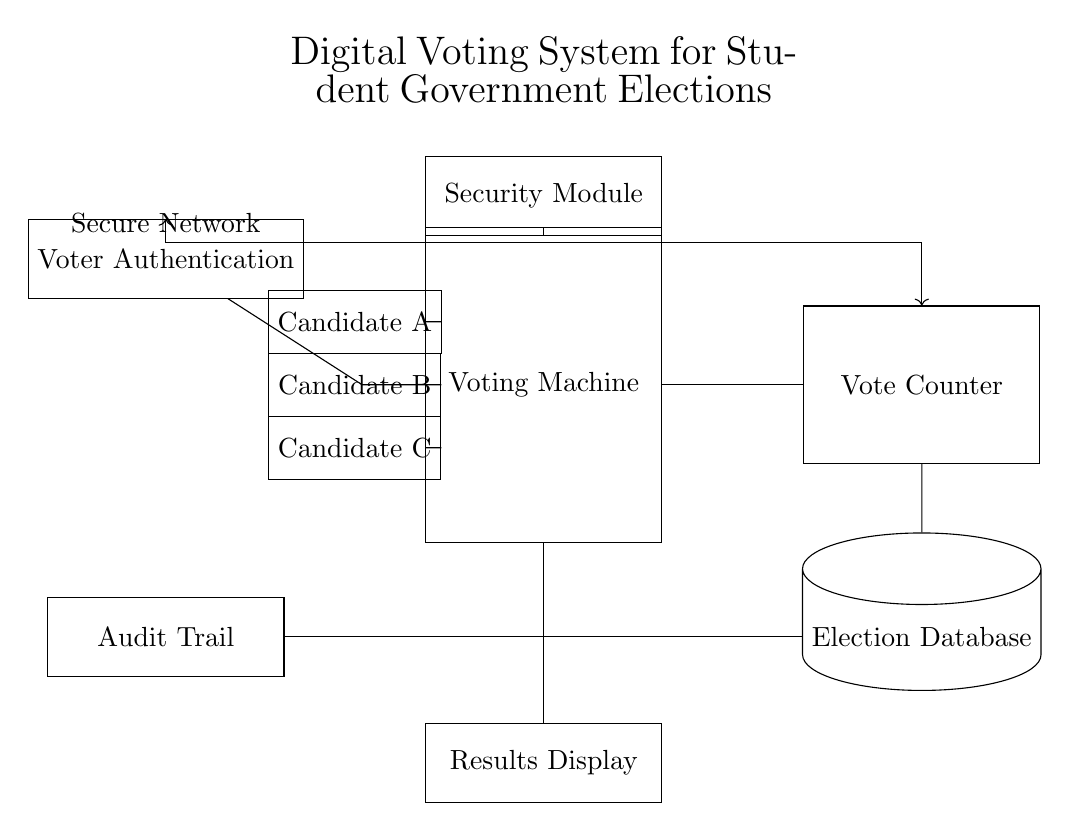What is the primary function of the voting machine? The voting machine's primary function is to facilitate the casting of votes for candidates A, B, and C. It connects voter authentication and ballot options to the vote counter, processing the voting actions.
Answer: Facilitate voting What component stores election data? The component storing the election data is the Election Database, which is depicted as a cylinder in the diagram. It receives information from the vote counter.
Answer: Election Database What does the Security Module ensure? The Security Module ensures the integrity and security of the voting process by safeguarding the connection between voters and the voting machine. It acts as a protective layer for voter transactions.
Answer: Integrity How are votes submitted from the voting machine? Votes are submitted through connections from the voting machine to the vote counter, which processes the collected votes. This flow is depicted by the arrows connecting these components.
Answer: Through connections Which component provides the final outcome of the voting process? The Results Display provides the final outcome of the voting process by showing the results after they are processed from the Election Database, indicating the candidates' vote counts.
Answer: Results Display What ensures voter authentication in the circuit? Voter authentication is ensured through the Voter Authentication component, which verifies the identity of voters before they interact with the voting machine.
Answer: Voter Authentication What type of connection is established between the vote counter and the voter? A secure network connection is established between the vote counter and the voter, ensuring that the voting data is transmitted safely. This is shown with an arrow labelled "Secure Network".
Answer: Secure Network 